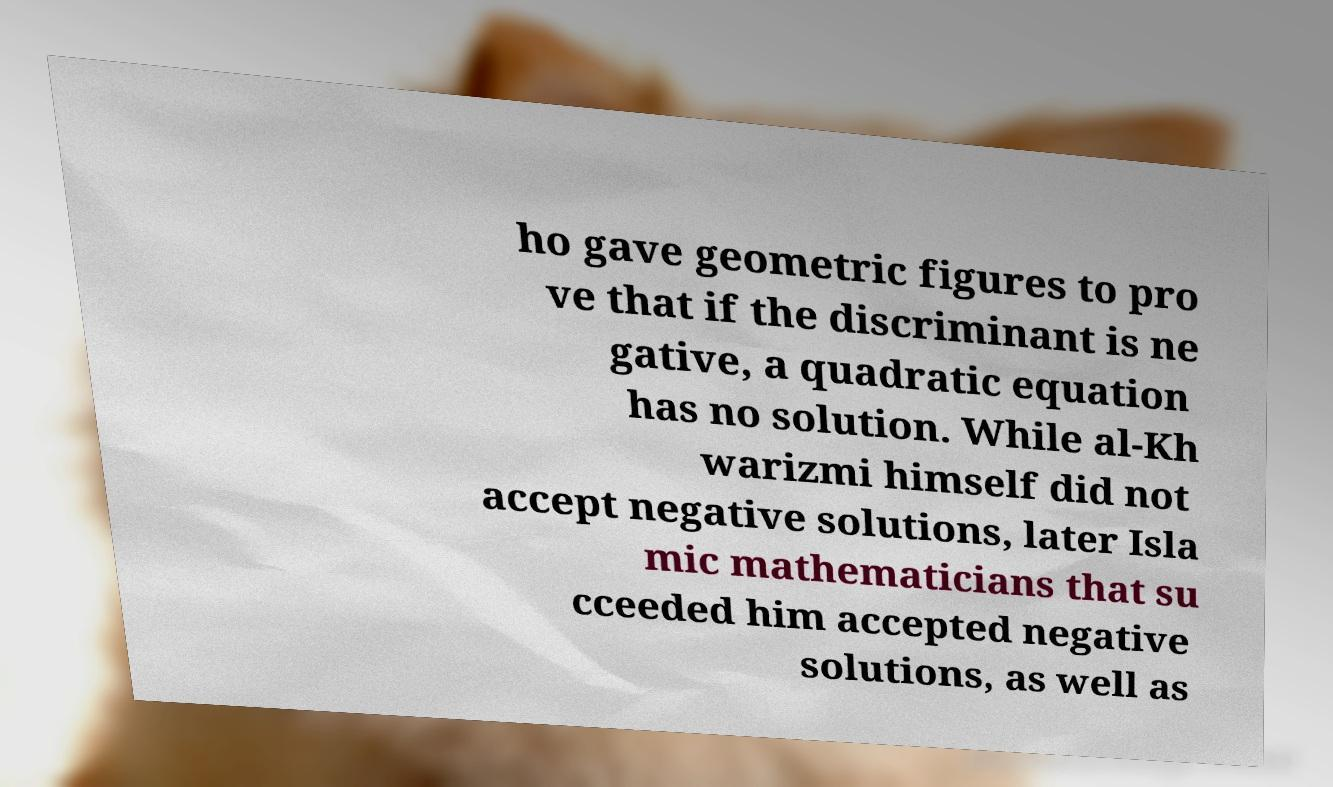Please read and relay the text visible in this image. What does it say? ho gave geometric figures to pro ve that if the discriminant is ne gative, a quadratic equation has no solution. While al-Kh warizmi himself did not accept negative solutions, later Isla mic mathematicians that su cceeded him accepted negative solutions, as well as 